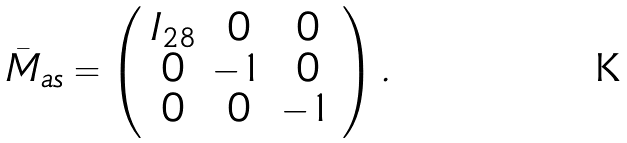Convert formula to latex. <formula><loc_0><loc_0><loc_500><loc_500>\bar { M } _ { a s } = \left ( \begin{array} { c c c } I _ { 2 8 } & 0 & 0 \\ 0 & - 1 & 0 \\ 0 & 0 & - 1 \end{array} \right ) .</formula> 